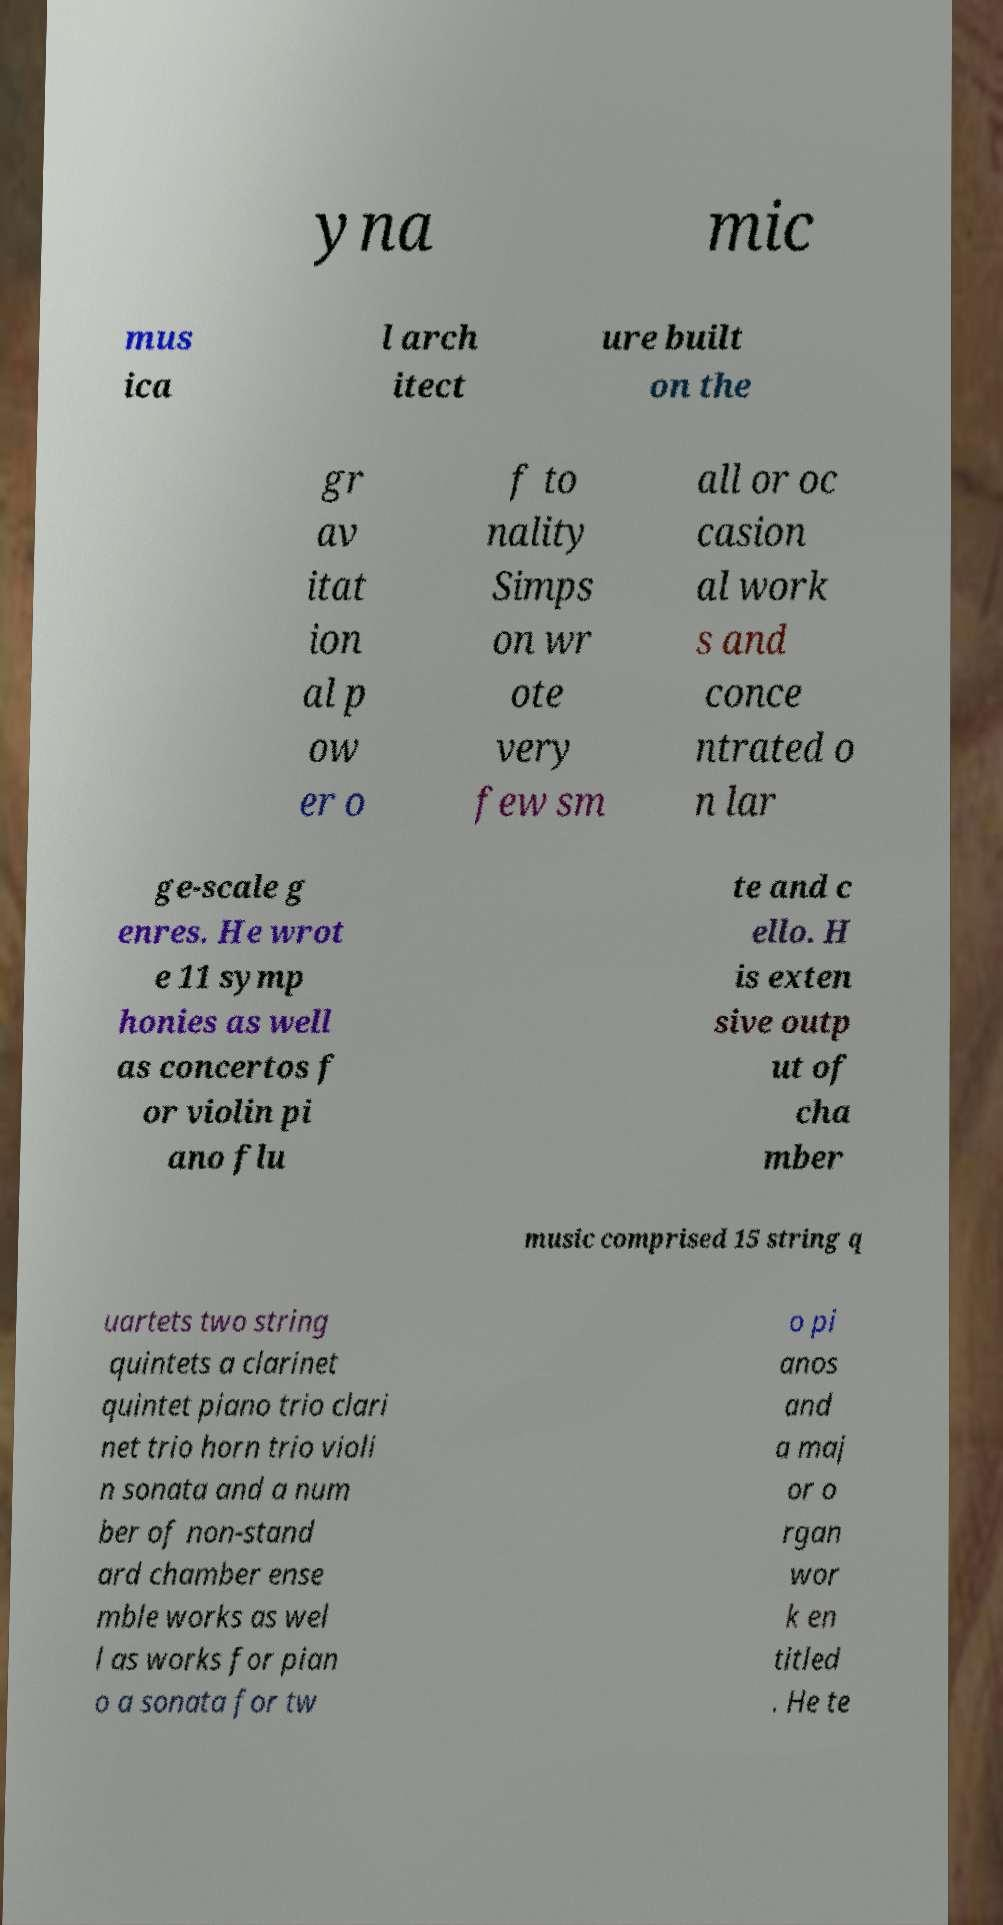There's text embedded in this image that I need extracted. Can you transcribe it verbatim? yna mic mus ica l arch itect ure built on the gr av itat ion al p ow er o f to nality Simps on wr ote very few sm all or oc casion al work s and conce ntrated o n lar ge-scale g enres. He wrot e 11 symp honies as well as concertos f or violin pi ano flu te and c ello. H is exten sive outp ut of cha mber music comprised 15 string q uartets two string quintets a clarinet quintet piano trio clari net trio horn trio violi n sonata and a num ber of non-stand ard chamber ense mble works as wel l as works for pian o a sonata for tw o pi anos and a maj or o rgan wor k en titled . He te 